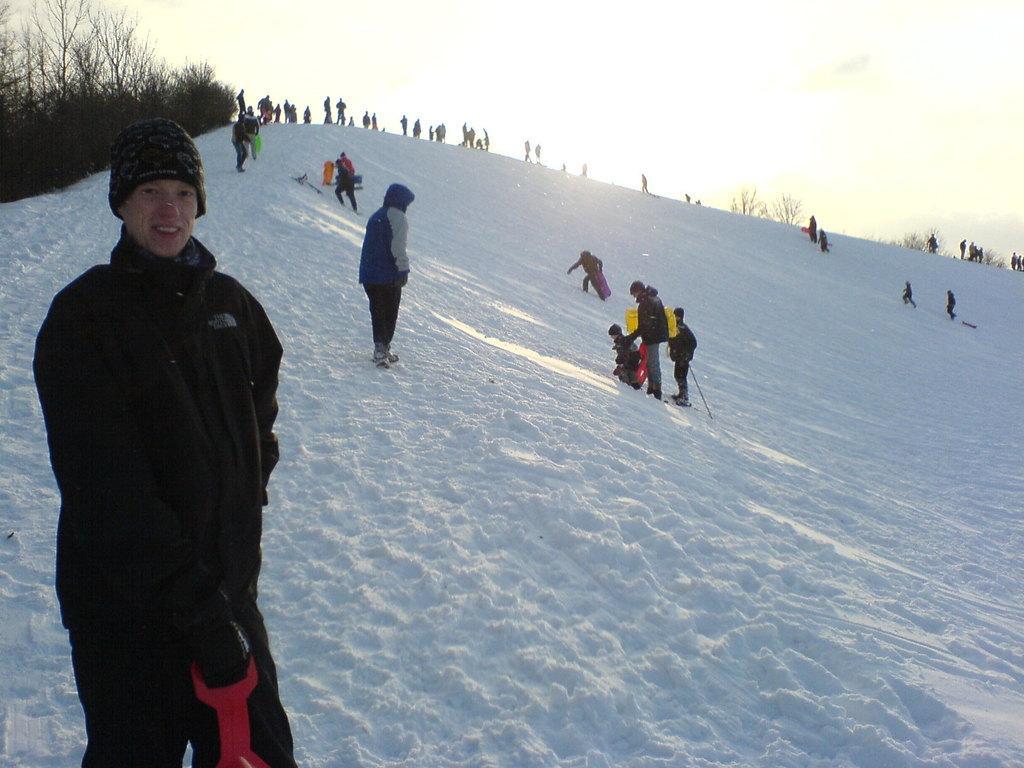Please provide a concise description of this image. In this picture I can see few people standing and few of them wore caps on their heads and I can see snow on the ground few trees and a cloudy sky. 